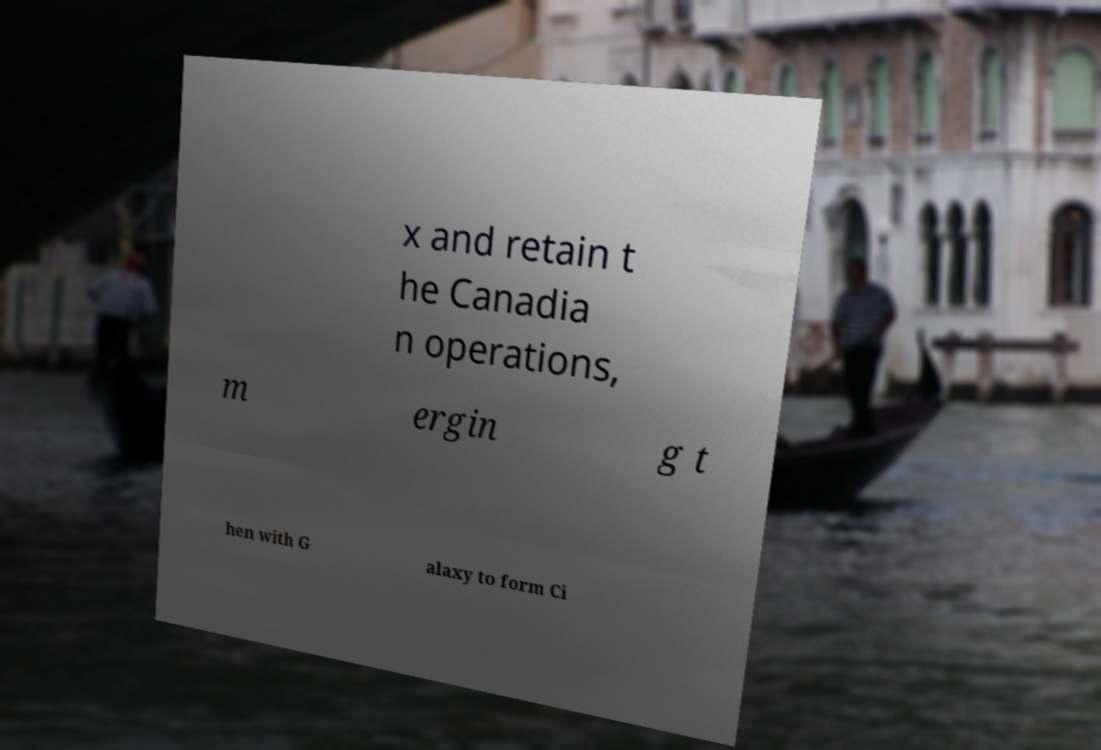Can you accurately transcribe the text from the provided image for me? x and retain t he Canadia n operations, m ergin g t hen with G alaxy to form Ci 